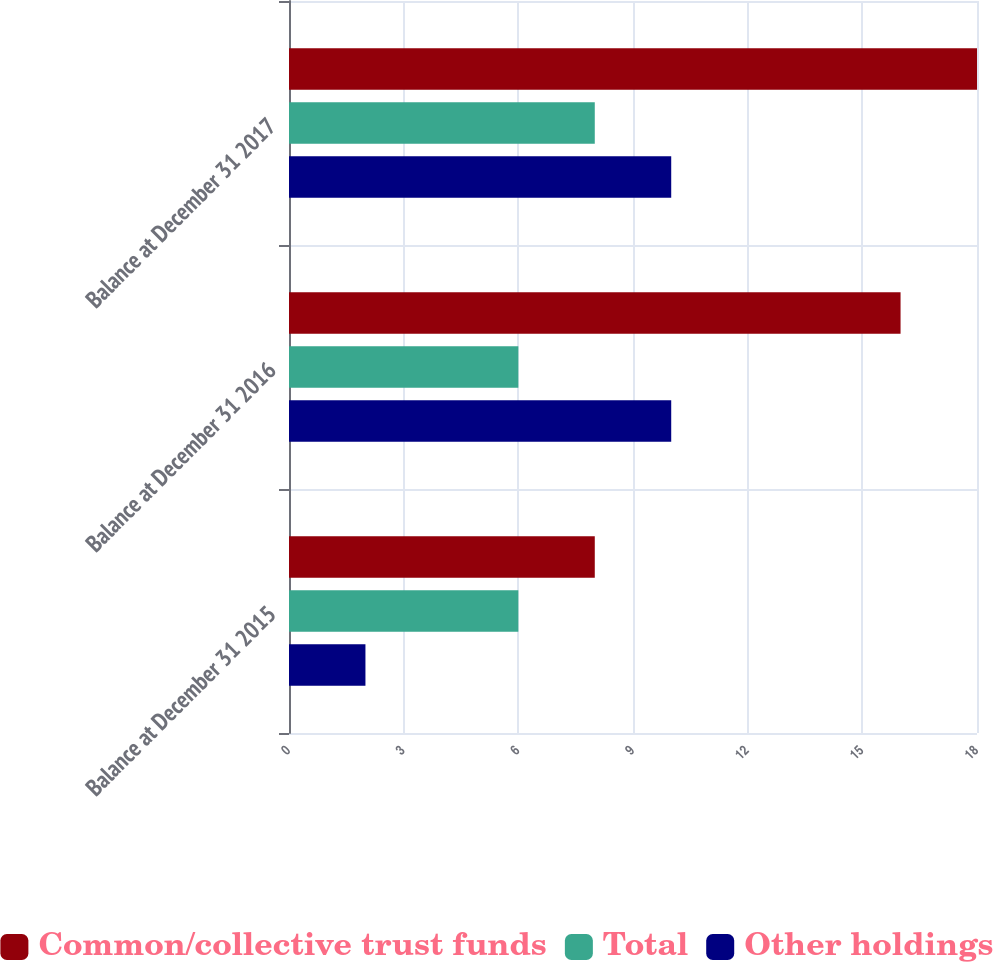<chart> <loc_0><loc_0><loc_500><loc_500><stacked_bar_chart><ecel><fcel>Balance at December 31 2015<fcel>Balance at December 31 2016<fcel>Balance at December 31 2017<nl><fcel>Common/collective trust funds<fcel>8<fcel>16<fcel>18<nl><fcel>Total<fcel>6<fcel>6<fcel>8<nl><fcel>Other holdings<fcel>2<fcel>10<fcel>10<nl></chart> 